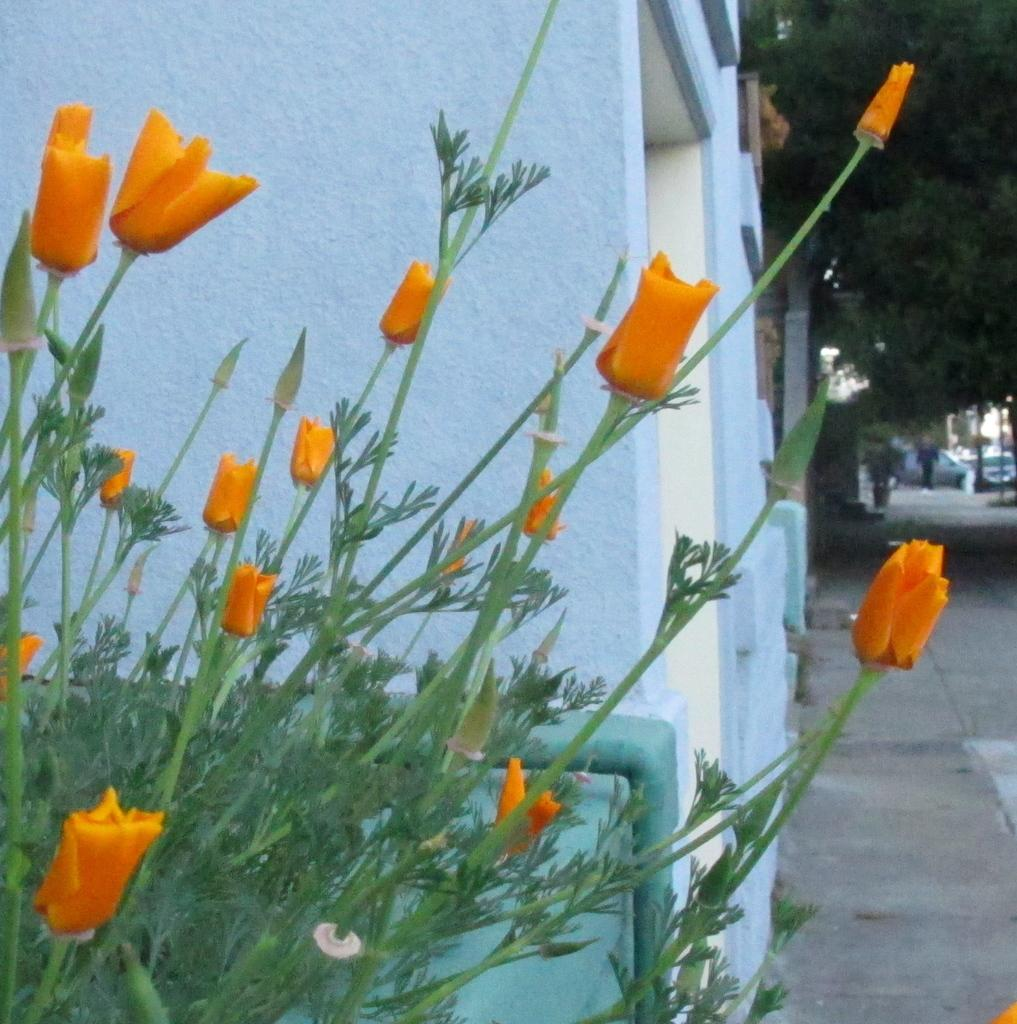What color are the flowers in the image? The flowers in the image are orange. What can be seen in the background of the image? There are buildings and trees in the background of the image. Are there any vehicles visible in the image? Yes, there are vehicles in the background of the image. What is the color of the trees in the background? The trees in the background are green. Can you describe the person in the image? There is a person walking in the image. What type of basketball is the mom painting in the image? There is no basketball or mom present in the image. What color is the paint being used to paint the basketball? There is no basketball or paint present in the image. 